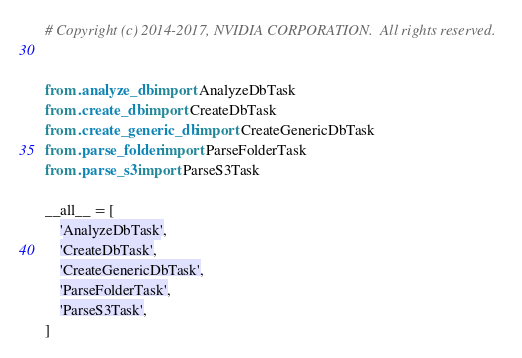<code> <loc_0><loc_0><loc_500><loc_500><_Python_># Copyright (c) 2014-2017, NVIDIA CORPORATION.  All rights reserved.


from .analyze_db import AnalyzeDbTask
from .create_db import CreateDbTask
from .create_generic_db import CreateGenericDbTask
from .parse_folder import ParseFolderTask
from .parse_s3 import ParseS3Task

__all__ = [
    'AnalyzeDbTask',
    'CreateDbTask',
    'CreateGenericDbTask',
    'ParseFolderTask',
    'ParseS3Task',
]
</code> 